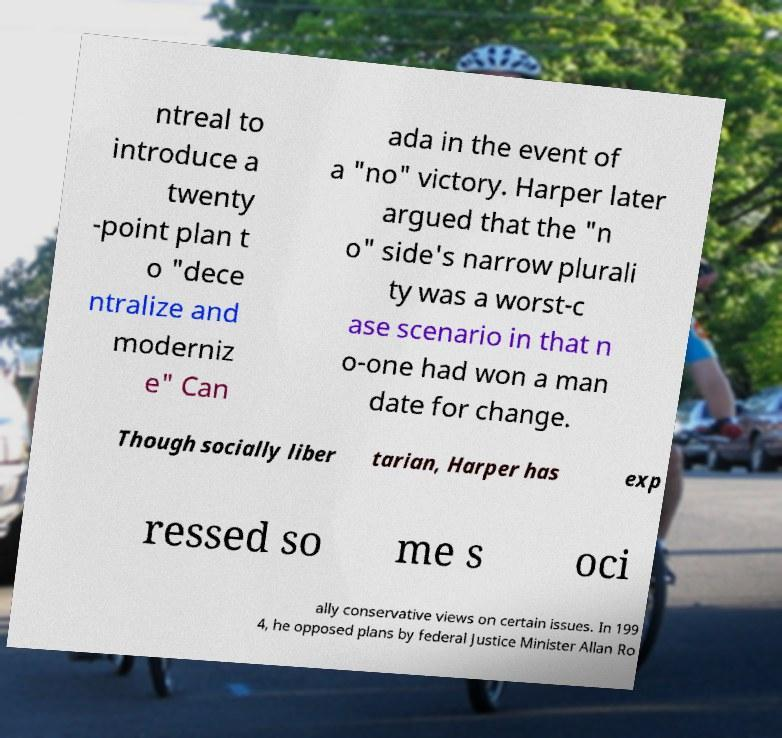I need the written content from this picture converted into text. Can you do that? ntreal to introduce a twenty -point plan t o "dece ntralize and moderniz e" Can ada in the event of a "no" victory. Harper later argued that the "n o" side's narrow plurali ty was a worst-c ase scenario in that n o-one had won a man date for change. Though socially liber tarian, Harper has exp ressed so me s oci ally conservative views on certain issues. In 199 4, he opposed plans by federal Justice Minister Allan Ro 